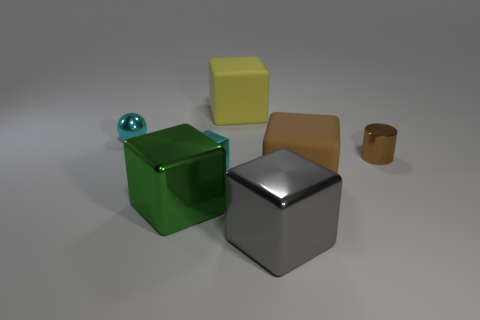There is a small brown metal cylinder; how many small brown things are on the right side of it?
Provide a short and direct response. 0. How many other things are there of the same shape as the big yellow thing?
Your answer should be very brief. 4. Is the number of brown cubes less than the number of tiny yellow matte things?
Provide a succinct answer. No. There is a cube that is behind the big brown cube and in front of the small ball; how big is it?
Make the answer very short. Small. There is a matte object that is in front of the big rubber thing that is left of the metallic cube that is to the right of the yellow object; what is its size?
Provide a succinct answer. Large. The brown shiny cylinder is what size?
Provide a succinct answer. Small. Are there any other things that are the same material as the gray object?
Ensure brevity in your answer.  Yes. There is a large metal block that is to the right of the block behind the tiny metallic ball; is there a yellow block to the right of it?
Your answer should be compact. No. What number of small things are cyan balls or matte things?
Give a very brief answer. 1. Is there anything else that has the same color as the metal cylinder?
Offer a terse response. Yes. 